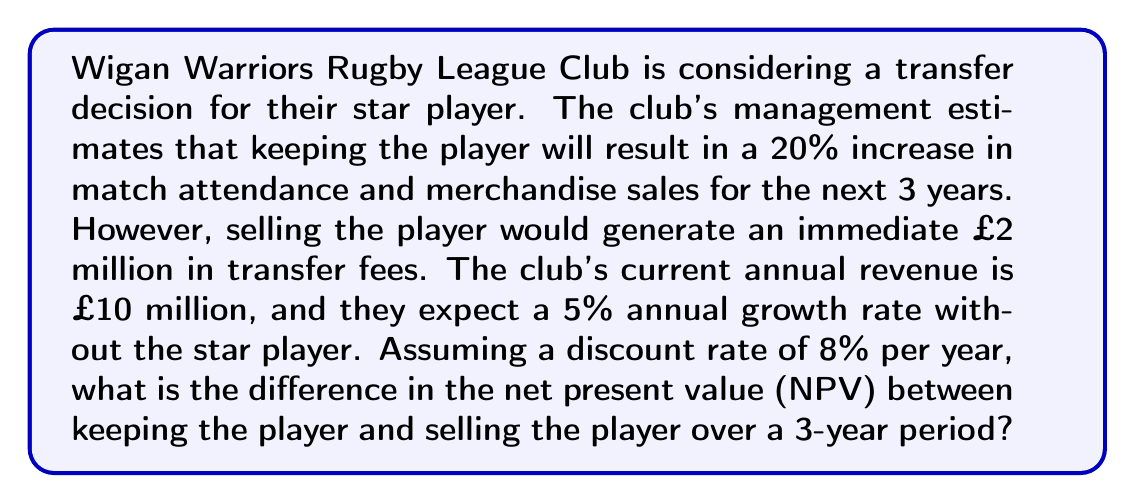What is the answer to this math problem? Let's approach this problem step by step:

1) First, we need to calculate the revenue streams for both scenarios:

   Scenario A: Keeping the player
   Year 1: £10m × 1.20 = £12m
   Year 2: £12m × 1.20 = £14.4m
   Year 3: £14.4m × 1.20 = £17.28m

   Scenario B: Selling the player
   Year 0: £2m (transfer fee)
   Year 1: £10m × 1.05 = £10.5m
   Year 2: £10.5m × 1.05 = £11.025m
   Year 3: £11.025m × 1.05 = £11.57625m

2) Now, we need to calculate the NPV for each scenario. The NPV formula is:

   $$NPV = \sum_{t=0}^{n} \frac{C_t}{(1+r)^t}$$

   Where $C_t$ is the cash flow at time t, r is the discount rate, and n is the number of periods.

3) For Scenario A (Keeping the player):

   $$NPV_A = \frac{12}{(1.08)^1} + \frac{14.4}{(1.08)^2} + \frac{17.28}{(1.08)^3}$$
   $$NPV_A = 11.11 + 12.35 + 13.72 = 37.18$$

4) For Scenario B (Selling the player):

   $$NPV_B = 2 + \frac{10.5}{(1.08)^1} + \frac{11.025}{(1.08)^2} + \frac{11.57625}{(1.08)^3}$$
   $$NPV_B = 2 + 9.72 + 9.45 + 9.19 = 30.36$$

5) The difference in NPV:

   $$NPV_A - NPV_B = 37.18 - 30.36 = 6.82$$

Therefore, the difference in NPV between keeping the player and selling the player over a 3-year period is £6.82 million.
Answer: £6.82 million 